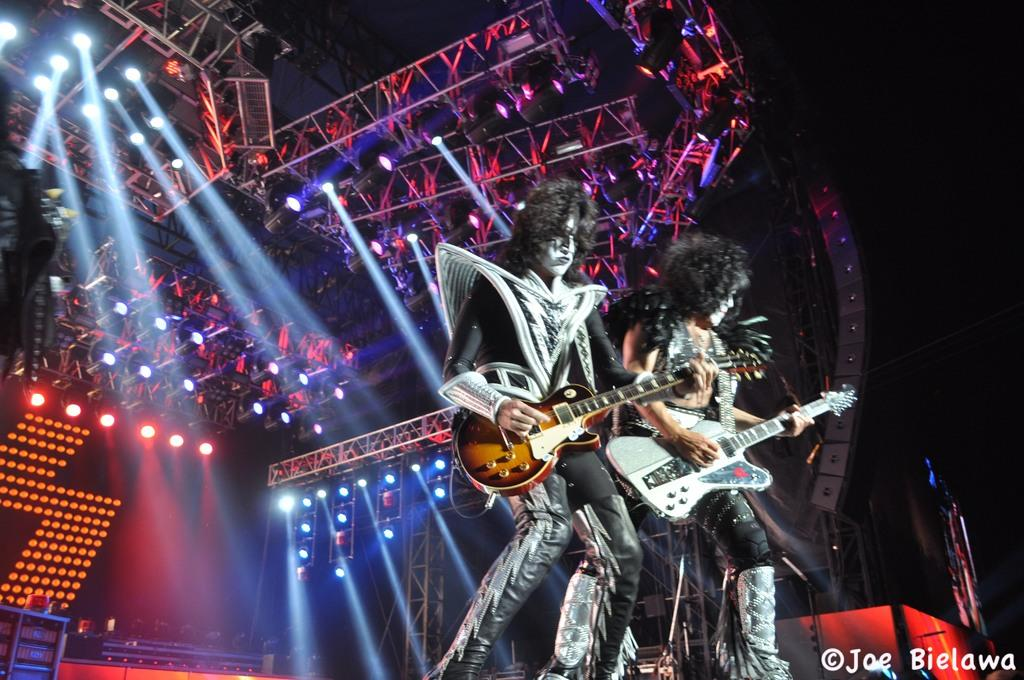How many people are in the image? There are two persons in the image. What are the persons doing in the image? The persons are standing and playing guitars. What can be seen in the background of the image? There are focusing lights and a screen in the background. What type of division can be seen between the two persons in the image? There is no division between the two persons in the image; they are standing side by side. What feeling is being expressed by the persons in the image? The image does not convey any specific feelings or emotions; it only shows the persons playing guitars. 